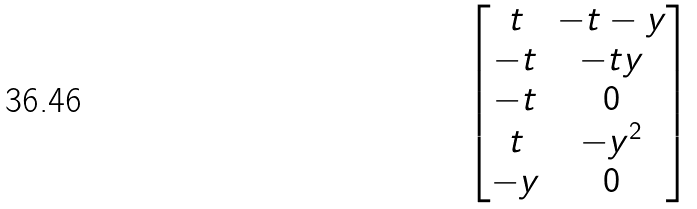Convert formula to latex. <formula><loc_0><loc_0><loc_500><loc_500>\begin{bmatrix} t & - t - y \\ - t & - t y \\ - t & 0 \\ t & - y ^ { 2 } \\ - y & 0 \end{bmatrix}</formula> 